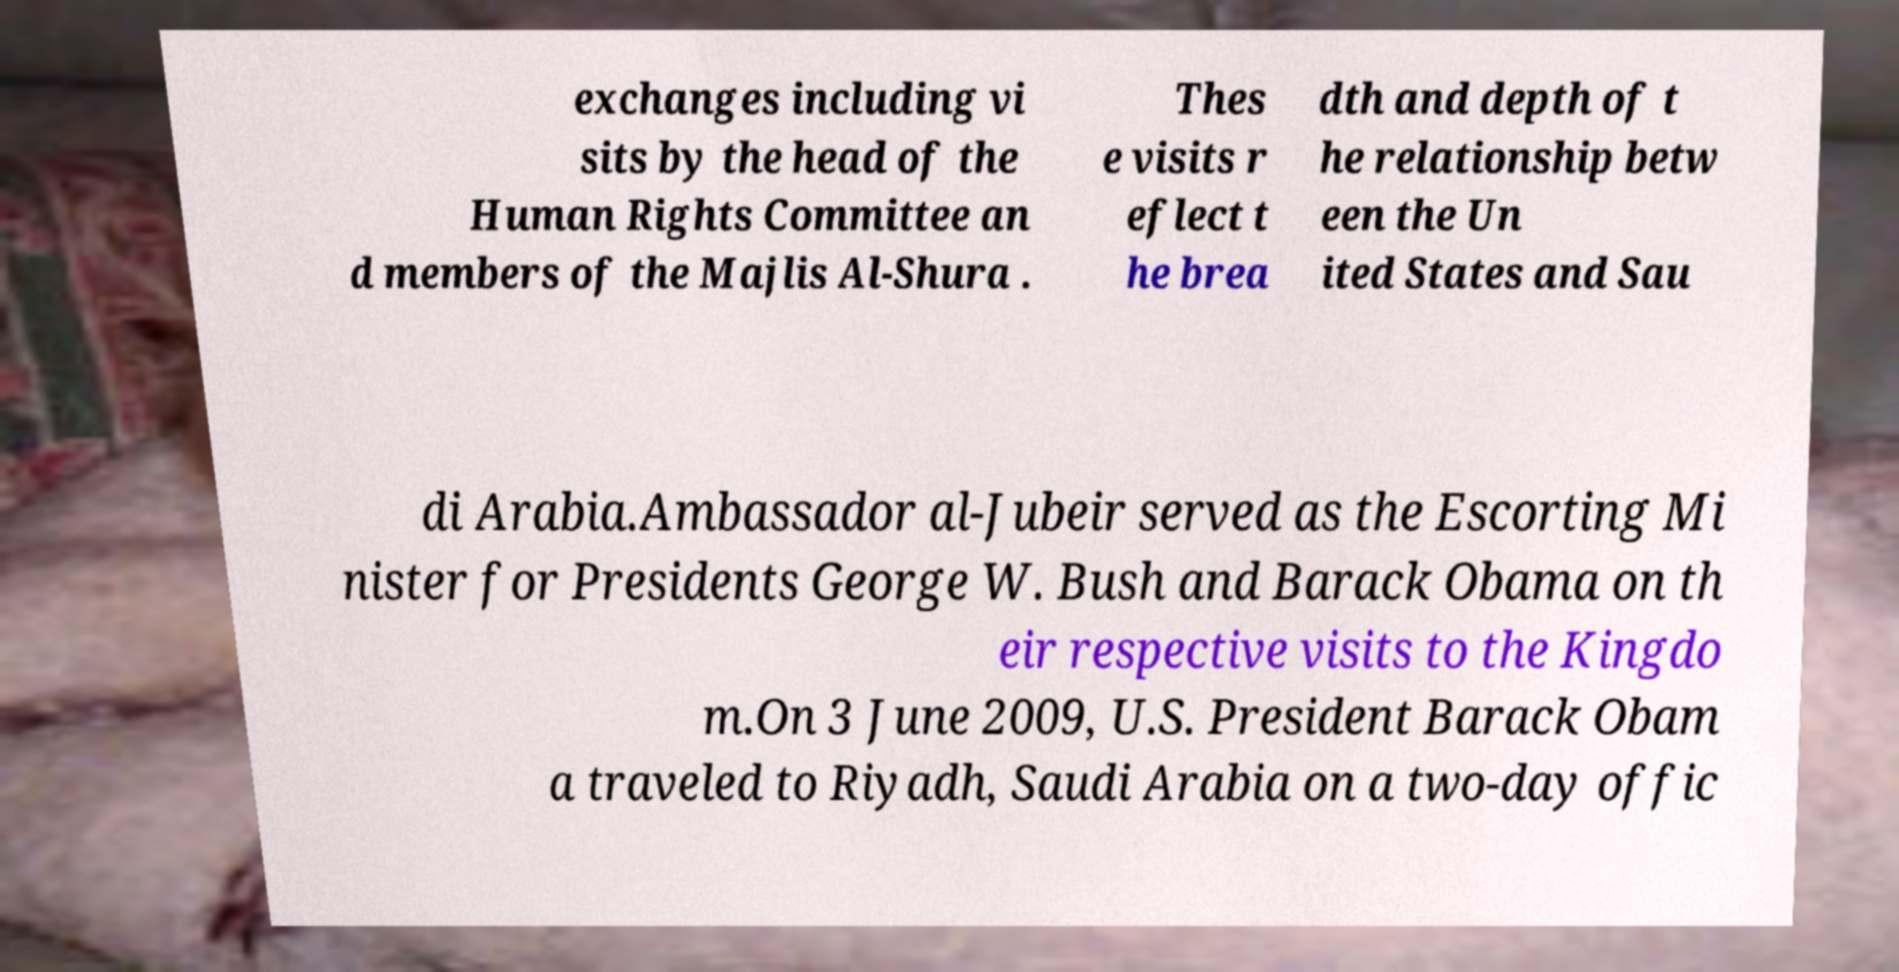For documentation purposes, I need the text within this image transcribed. Could you provide that? exchanges including vi sits by the head of the Human Rights Committee an d members of the Majlis Al-Shura . Thes e visits r eflect t he brea dth and depth of t he relationship betw een the Un ited States and Sau di Arabia.Ambassador al-Jubeir served as the Escorting Mi nister for Presidents George W. Bush and Barack Obama on th eir respective visits to the Kingdo m.On 3 June 2009, U.S. President Barack Obam a traveled to Riyadh, Saudi Arabia on a two-day offic 